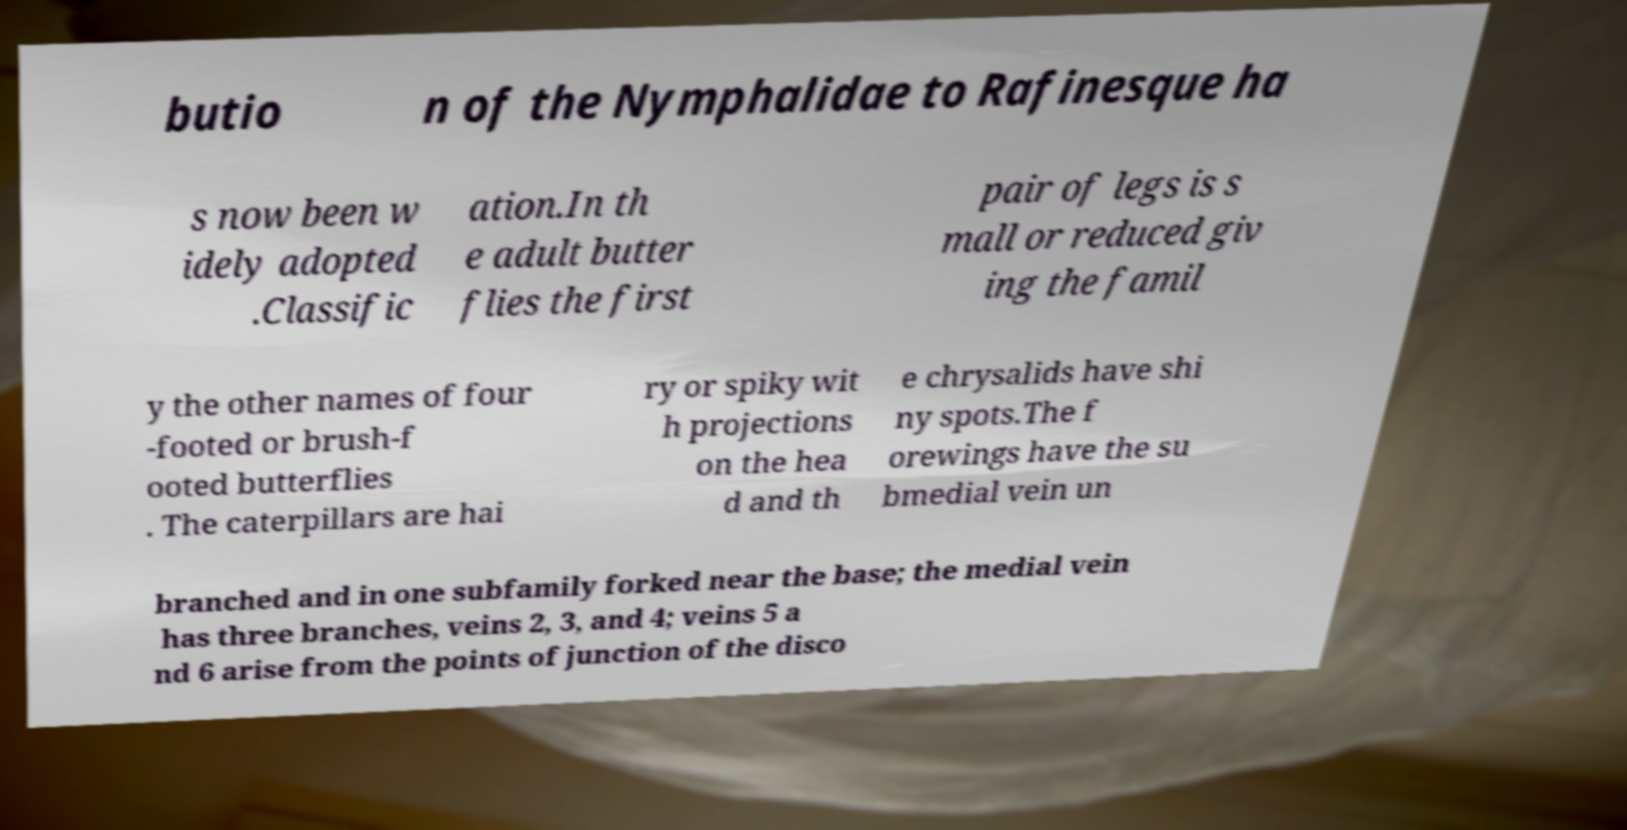What messages or text are displayed in this image? I need them in a readable, typed format. butio n of the Nymphalidae to Rafinesque ha s now been w idely adopted .Classific ation.In th e adult butter flies the first pair of legs is s mall or reduced giv ing the famil y the other names of four -footed or brush-f ooted butterflies . The caterpillars are hai ry or spiky wit h projections on the hea d and th e chrysalids have shi ny spots.The f orewings have the su bmedial vein un branched and in one subfamily forked near the base; the medial vein has three branches, veins 2, 3, and 4; veins 5 a nd 6 arise from the points of junction of the disco 